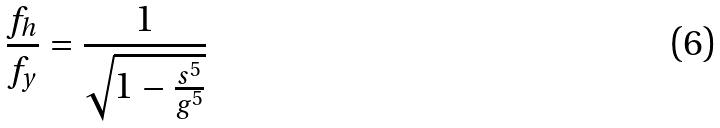<formula> <loc_0><loc_0><loc_500><loc_500>\frac { f _ { h } } { f _ { y } } = \frac { 1 } { \sqrt { 1 - \frac { s ^ { 5 } } { g ^ { 5 } } } }</formula> 